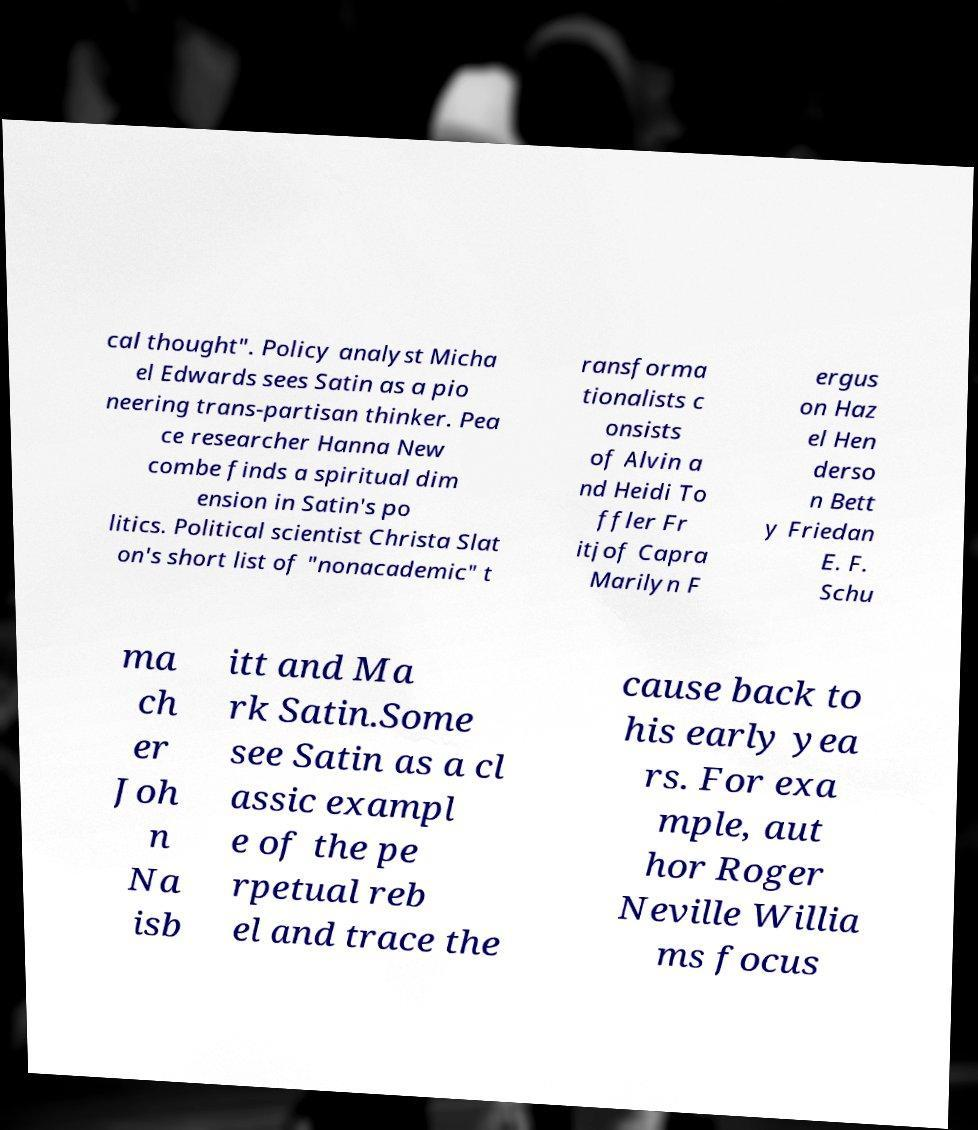There's text embedded in this image that I need extracted. Can you transcribe it verbatim? cal thought". Policy analyst Micha el Edwards sees Satin as a pio neering trans-partisan thinker. Pea ce researcher Hanna New combe finds a spiritual dim ension in Satin's po litics. Political scientist Christa Slat on's short list of "nonacademic" t ransforma tionalists c onsists of Alvin a nd Heidi To ffler Fr itjof Capra Marilyn F ergus on Haz el Hen derso n Bett y Friedan E. F. Schu ma ch er Joh n Na isb itt and Ma rk Satin.Some see Satin as a cl assic exampl e of the pe rpetual reb el and trace the cause back to his early yea rs. For exa mple, aut hor Roger Neville Willia ms focus 